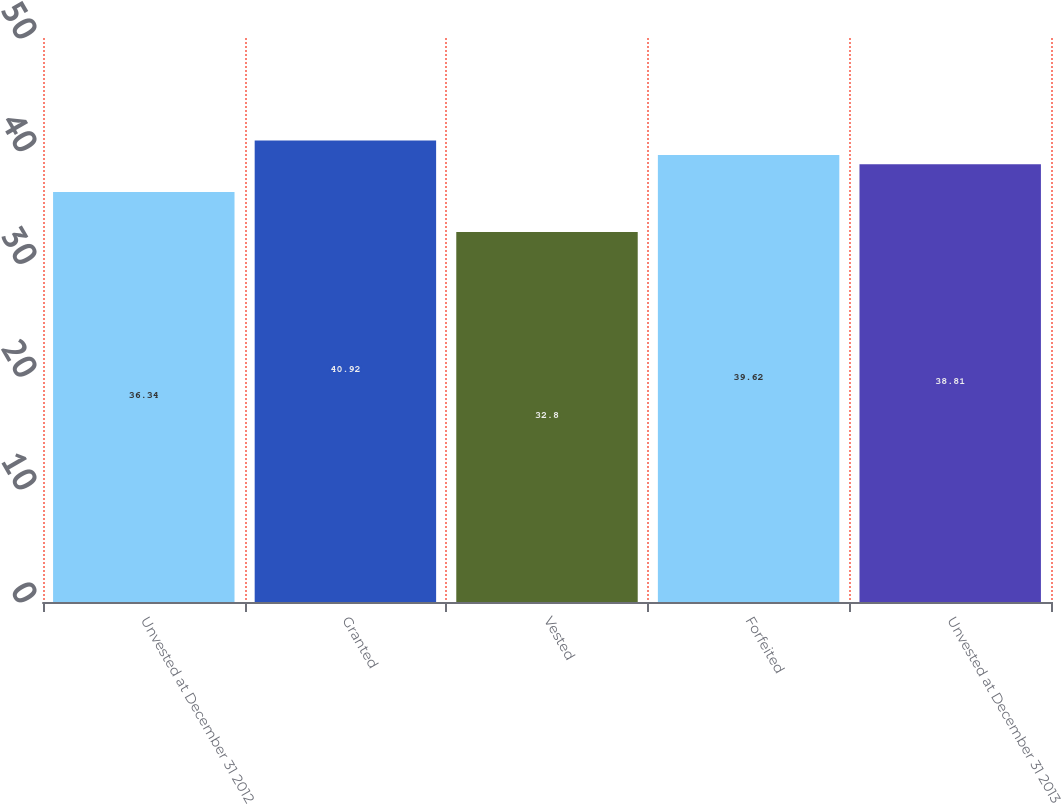Convert chart to OTSL. <chart><loc_0><loc_0><loc_500><loc_500><bar_chart><fcel>Unvested at December 31 2012<fcel>Granted<fcel>Vested<fcel>Forfeited<fcel>Unvested at December 31 2013<nl><fcel>36.34<fcel>40.92<fcel>32.8<fcel>39.62<fcel>38.81<nl></chart> 